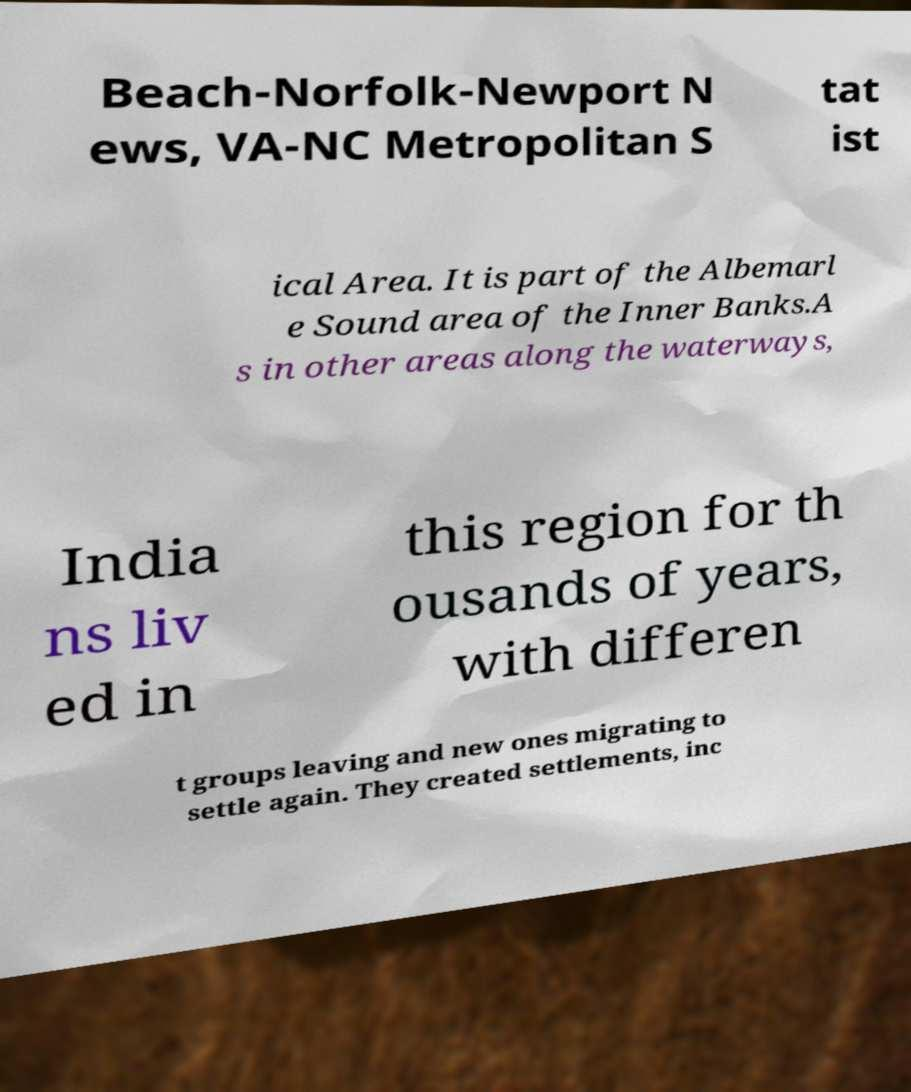Could you assist in decoding the text presented in this image and type it out clearly? Beach-Norfolk-Newport N ews, VA-NC Metropolitan S tat ist ical Area. It is part of the Albemarl e Sound area of the Inner Banks.A s in other areas along the waterways, India ns liv ed in this region for th ousands of years, with differen t groups leaving and new ones migrating to settle again. They created settlements, inc 